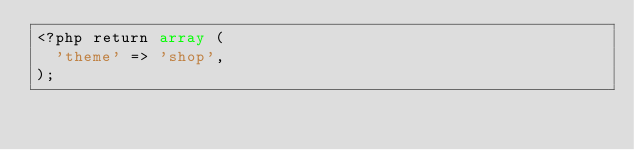<code> <loc_0><loc_0><loc_500><loc_500><_PHP_><?php return array (
  'theme' => 'shop',
);</code> 